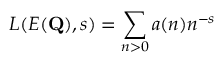Convert formula to latex. <formula><loc_0><loc_0><loc_500><loc_500>L ( E ( Q ) , s ) = \sum _ { n > 0 } a ( n ) n ^ { - s }</formula> 